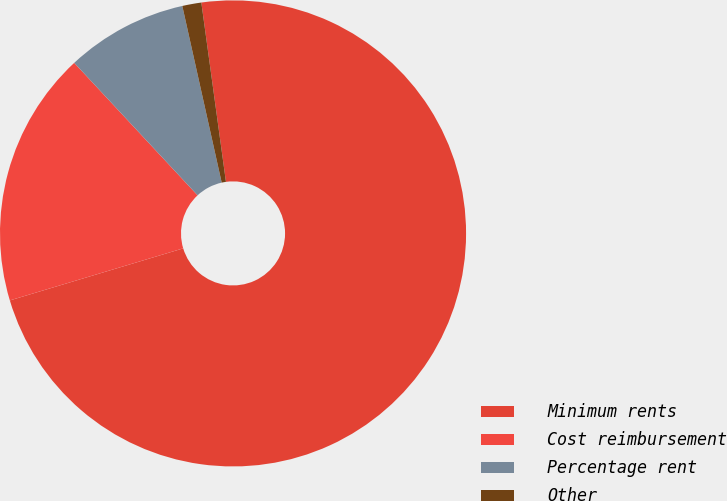Convert chart. <chart><loc_0><loc_0><loc_500><loc_500><pie_chart><fcel>Minimum rents<fcel>Cost reimbursement<fcel>Percentage rent<fcel>Other<nl><fcel>72.53%<fcel>17.71%<fcel>8.44%<fcel>1.32%<nl></chart> 